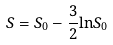Convert formula to latex. <formula><loc_0><loc_0><loc_500><loc_500>S = S _ { 0 } - \frac { 3 } { 2 } { \ln } S _ { 0 }</formula> 